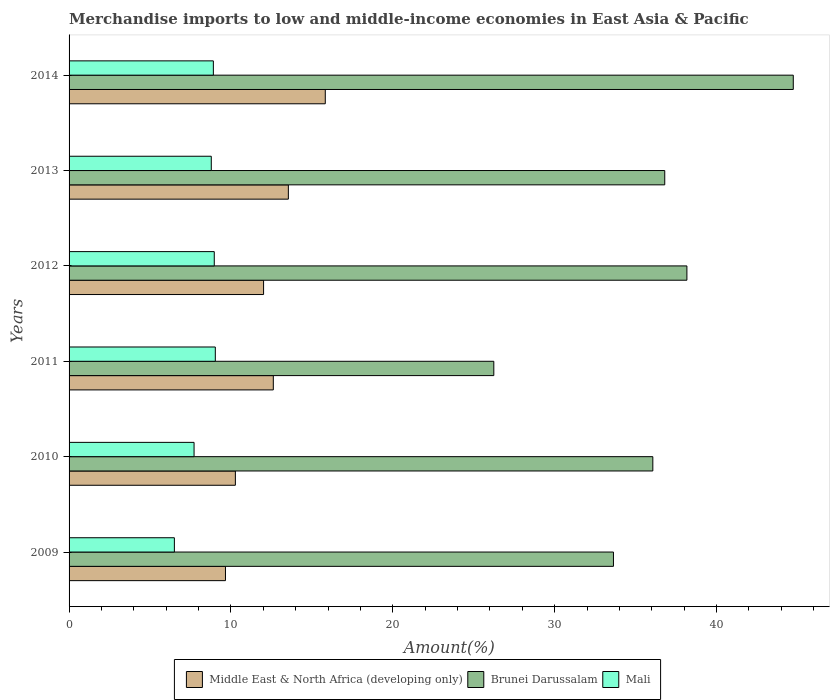How many different coloured bars are there?
Your answer should be very brief. 3. Are the number of bars per tick equal to the number of legend labels?
Your answer should be very brief. Yes. How many bars are there on the 6th tick from the top?
Ensure brevity in your answer.  3. How many bars are there on the 6th tick from the bottom?
Offer a terse response. 3. What is the percentage of amount earned from merchandise imports in Brunei Darussalam in 2011?
Give a very brief answer. 26.24. Across all years, what is the maximum percentage of amount earned from merchandise imports in Mali?
Ensure brevity in your answer.  9.04. Across all years, what is the minimum percentage of amount earned from merchandise imports in Brunei Darussalam?
Offer a terse response. 26.24. What is the total percentage of amount earned from merchandise imports in Middle East & North Africa (developing only) in the graph?
Offer a very short reply. 73.95. What is the difference between the percentage of amount earned from merchandise imports in Middle East & North Africa (developing only) in 2009 and that in 2012?
Ensure brevity in your answer.  -2.35. What is the difference between the percentage of amount earned from merchandise imports in Middle East & North Africa (developing only) in 2010 and the percentage of amount earned from merchandise imports in Mali in 2014?
Your answer should be compact. 1.36. What is the average percentage of amount earned from merchandise imports in Mali per year?
Provide a short and direct response. 8.32. In the year 2012, what is the difference between the percentage of amount earned from merchandise imports in Middle East & North Africa (developing only) and percentage of amount earned from merchandise imports in Mali?
Provide a succinct answer. 3.05. What is the ratio of the percentage of amount earned from merchandise imports in Middle East & North Africa (developing only) in 2011 to that in 2014?
Make the answer very short. 0.8. Is the percentage of amount earned from merchandise imports in Mali in 2009 less than that in 2010?
Make the answer very short. Yes. Is the difference between the percentage of amount earned from merchandise imports in Middle East & North Africa (developing only) in 2010 and 2012 greater than the difference between the percentage of amount earned from merchandise imports in Mali in 2010 and 2012?
Keep it short and to the point. No. What is the difference between the highest and the second highest percentage of amount earned from merchandise imports in Mali?
Provide a succinct answer. 0.06. What is the difference between the highest and the lowest percentage of amount earned from merchandise imports in Middle East & North Africa (developing only)?
Keep it short and to the point. 6.17. Is the sum of the percentage of amount earned from merchandise imports in Mali in 2012 and 2013 greater than the maximum percentage of amount earned from merchandise imports in Brunei Darussalam across all years?
Your response must be concise. No. What does the 2nd bar from the top in 2013 represents?
Offer a terse response. Brunei Darussalam. What does the 1st bar from the bottom in 2014 represents?
Offer a very short reply. Middle East & North Africa (developing only). How many bars are there?
Offer a very short reply. 18. Are all the bars in the graph horizontal?
Provide a succinct answer. Yes. How many years are there in the graph?
Make the answer very short. 6. What is the difference between two consecutive major ticks on the X-axis?
Keep it short and to the point. 10. Does the graph contain grids?
Ensure brevity in your answer.  No. How many legend labels are there?
Offer a very short reply. 3. How are the legend labels stacked?
Make the answer very short. Horizontal. What is the title of the graph?
Offer a very short reply. Merchandise imports to low and middle-income economies in East Asia & Pacific. What is the label or title of the X-axis?
Ensure brevity in your answer.  Amount(%). What is the label or title of the Y-axis?
Give a very brief answer. Years. What is the Amount(%) of Middle East & North Africa (developing only) in 2009?
Your answer should be very brief. 9.66. What is the Amount(%) in Brunei Darussalam in 2009?
Your answer should be very brief. 33.63. What is the Amount(%) of Mali in 2009?
Your answer should be compact. 6.51. What is the Amount(%) in Middle East & North Africa (developing only) in 2010?
Give a very brief answer. 10.28. What is the Amount(%) in Brunei Darussalam in 2010?
Provide a short and direct response. 36.07. What is the Amount(%) in Mali in 2010?
Your answer should be very brief. 7.72. What is the Amount(%) in Middle East & North Africa (developing only) in 2011?
Keep it short and to the point. 12.62. What is the Amount(%) in Brunei Darussalam in 2011?
Keep it short and to the point. 26.24. What is the Amount(%) of Mali in 2011?
Keep it short and to the point. 9.04. What is the Amount(%) in Middle East & North Africa (developing only) in 2012?
Keep it short and to the point. 12.02. What is the Amount(%) in Brunei Darussalam in 2012?
Give a very brief answer. 38.17. What is the Amount(%) of Mali in 2012?
Your answer should be compact. 8.97. What is the Amount(%) of Middle East & North Africa (developing only) in 2013?
Ensure brevity in your answer.  13.55. What is the Amount(%) of Brunei Darussalam in 2013?
Provide a short and direct response. 36.8. What is the Amount(%) in Mali in 2013?
Keep it short and to the point. 8.79. What is the Amount(%) in Middle East & North Africa (developing only) in 2014?
Your response must be concise. 15.83. What is the Amount(%) in Brunei Darussalam in 2014?
Provide a short and direct response. 44.74. What is the Amount(%) of Mali in 2014?
Provide a succinct answer. 8.91. Across all years, what is the maximum Amount(%) of Middle East & North Africa (developing only)?
Your answer should be compact. 15.83. Across all years, what is the maximum Amount(%) in Brunei Darussalam?
Make the answer very short. 44.74. Across all years, what is the maximum Amount(%) of Mali?
Provide a short and direct response. 9.04. Across all years, what is the minimum Amount(%) in Middle East & North Africa (developing only)?
Offer a very short reply. 9.66. Across all years, what is the minimum Amount(%) in Brunei Darussalam?
Offer a terse response. 26.24. Across all years, what is the minimum Amount(%) in Mali?
Provide a succinct answer. 6.51. What is the total Amount(%) in Middle East & North Africa (developing only) in the graph?
Make the answer very short. 73.95. What is the total Amount(%) of Brunei Darussalam in the graph?
Provide a succinct answer. 215.67. What is the total Amount(%) in Mali in the graph?
Your response must be concise. 49.94. What is the difference between the Amount(%) of Middle East & North Africa (developing only) in 2009 and that in 2010?
Offer a terse response. -0.61. What is the difference between the Amount(%) of Brunei Darussalam in 2009 and that in 2010?
Offer a very short reply. -2.43. What is the difference between the Amount(%) of Mali in 2009 and that in 2010?
Ensure brevity in your answer.  -1.22. What is the difference between the Amount(%) of Middle East & North Africa (developing only) in 2009 and that in 2011?
Ensure brevity in your answer.  -2.96. What is the difference between the Amount(%) in Brunei Darussalam in 2009 and that in 2011?
Provide a short and direct response. 7.39. What is the difference between the Amount(%) of Mali in 2009 and that in 2011?
Offer a very short reply. -2.53. What is the difference between the Amount(%) of Middle East & North Africa (developing only) in 2009 and that in 2012?
Your response must be concise. -2.35. What is the difference between the Amount(%) in Brunei Darussalam in 2009 and that in 2012?
Offer a terse response. -4.54. What is the difference between the Amount(%) in Mali in 2009 and that in 2012?
Your response must be concise. -2.46. What is the difference between the Amount(%) of Middle East & North Africa (developing only) in 2009 and that in 2013?
Provide a succinct answer. -3.89. What is the difference between the Amount(%) in Brunei Darussalam in 2009 and that in 2013?
Keep it short and to the point. -3.17. What is the difference between the Amount(%) in Mali in 2009 and that in 2013?
Ensure brevity in your answer.  -2.28. What is the difference between the Amount(%) in Middle East & North Africa (developing only) in 2009 and that in 2014?
Give a very brief answer. -6.17. What is the difference between the Amount(%) of Brunei Darussalam in 2009 and that in 2014?
Make the answer very short. -11.11. What is the difference between the Amount(%) of Mali in 2009 and that in 2014?
Keep it short and to the point. -2.41. What is the difference between the Amount(%) of Middle East & North Africa (developing only) in 2010 and that in 2011?
Keep it short and to the point. -2.34. What is the difference between the Amount(%) of Brunei Darussalam in 2010 and that in 2011?
Offer a very short reply. 9.82. What is the difference between the Amount(%) of Mali in 2010 and that in 2011?
Your answer should be very brief. -1.31. What is the difference between the Amount(%) of Middle East & North Africa (developing only) in 2010 and that in 2012?
Give a very brief answer. -1.74. What is the difference between the Amount(%) in Brunei Darussalam in 2010 and that in 2012?
Provide a succinct answer. -2.11. What is the difference between the Amount(%) of Mali in 2010 and that in 2012?
Your answer should be compact. -1.25. What is the difference between the Amount(%) of Middle East & North Africa (developing only) in 2010 and that in 2013?
Give a very brief answer. -3.27. What is the difference between the Amount(%) in Brunei Darussalam in 2010 and that in 2013?
Make the answer very short. -0.74. What is the difference between the Amount(%) of Mali in 2010 and that in 2013?
Provide a short and direct response. -1.06. What is the difference between the Amount(%) of Middle East & North Africa (developing only) in 2010 and that in 2014?
Keep it short and to the point. -5.55. What is the difference between the Amount(%) in Brunei Darussalam in 2010 and that in 2014?
Your response must be concise. -8.68. What is the difference between the Amount(%) of Mali in 2010 and that in 2014?
Your response must be concise. -1.19. What is the difference between the Amount(%) of Middle East & North Africa (developing only) in 2011 and that in 2012?
Offer a very short reply. 0.6. What is the difference between the Amount(%) of Brunei Darussalam in 2011 and that in 2012?
Make the answer very short. -11.93. What is the difference between the Amount(%) of Mali in 2011 and that in 2012?
Your response must be concise. 0.06. What is the difference between the Amount(%) of Middle East & North Africa (developing only) in 2011 and that in 2013?
Your answer should be very brief. -0.93. What is the difference between the Amount(%) of Brunei Darussalam in 2011 and that in 2013?
Your answer should be compact. -10.56. What is the difference between the Amount(%) of Mali in 2011 and that in 2013?
Your answer should be compact. 0.25. What is the difference between the Amount(%) in Middle East & North Africa (developing only) in 2011 and that in 2014?
Offer a terse response. -3.21. What is the difference between the Amount(%) of Brunei Darussalam in 2011 and that in 2014?
Provide a succinct answer. -18.5. What is the difference between the Amount(%) in Mali in 2011 and that in 2014?
Keep it short and to the point. 0.12. What is the difference between the Amount(%) of Middle East & North Africa (developing only) in 2012 and that in 2013?
Ensure brevity in your answer.  -1.53. What is the difference between the Amount(%) of Brunei Darussalam in 2012 and that in 2013?
Keep it short and to the point. 1.37. What is the difference between the Amount(%) of Mali in 2012 and that in 2013?
Give a very brief answer. 0.18. What is the difference between the Amount(%) in Middle East & North Africa (developing only) in 2012 and that in 2014?
Offer a very short reply. -3.81. What is the difference between the Amount(%) in Brunei Darussalam in 2012 and that in 2014?
Your response must be concise. -6.57. What is the difference between the Amount(%) in Mali in 2012 and that in 2014?
Provide a short and direct response. 0.06. What is the difference between the Amount(%) of Middle East & North Africa (developing only) in 2013 and that in 2014?
Provide a succinct answer. -2.28. What is the difference between the Amount(%) in Brunei Darussalam in 2013 and that in 2014?
Provide a succinct answer. -7.94. What is the difference between the Amount(%) in Mali in 2013 and that in 2014?
Keep it short and to the point. -0.13. What is the difference between the Amount(%) of Middle East & North Africa (developing only) in 2009 and the Amount(%) of Brunei Darussalam in 2010?
Offer a terse response. -26.4. What is the difference between the Amount(%) in Middle East & North Africa (developing only) in 2009 and the Amount(%) in Mali in 2010?
Provide a succinct answer. 1.94. What is the difference between the Amount(%) of Brunei Darussalam in 2009 and the Amount(%) of Mali in 2010?
Ensure brevity in your answer.  25.91. What is the difference between the Amount(%) of Middle East & North Africa (developing only) in 2009 and the Amount(%) of Brunei Darussalam in 2011?
Make the answer very short. -16.58. What is the difference between the Amount(%) in Middle East & North Africa (developing only) in 2009 and the Amount(%) in Mali in 2011?
Your answer should be compact. 0.63. What is the difference between the Amount(%) in Brunei Darussalam in 2009 and the Amount(%) in Mali in 2011?
Offer a very short reply. 24.6. What is the difference between the Amount(%) in Middle East & North Africa (developing only) in 2009 and the Amount(%) in Brunei Darussalam in 2012?
Give a very brief answer. -28.51. What is the difference between the Amount(%) in Middle East & North Africa (developing only) in 2009 and the Amount(%) in Mali in 2012?
Your response must be concise. 0.69. What is the difference between the Amount(%) of Brunei Darussalam in 2009 and the Amount(%) of Mali in 2012?
Provide a succinct answer. 24.66. What is the difference between the Amount(%) in Middle East & North Africa (developing only) in 2009 and the Amount(%) in Brunei Darussalam in 2013?
Keep it short and to the point. -27.14. What is the difference between the Amount(%) in Middle East & North Africa (developing only) in 2009 and the Amount(%) in Mali in 2013?
Your answer should be compact. 0.88. What is the difference between the Amount(%) in Brunei Darussalam in 2009 and the Amount(%) in Mali in 2013?
Your answer should be compact. 24.85. What is the difference between the Amount(%) of Middle East & North Africa (developing only) in 2009 and the Amount(%) of Brunei Darussalam in 2014?
Offer a very short reply. -35.08. What is the difference between the Amount(%) in Middle East & North Africa (developing only) in 2009 and the Amount(%) in Mali in 2014?
Your response must be concise. 0.75. What is the difference between the Amount(%) of Brunei Darussalam in 2009 and the Amount(%) of Mali in 2014?
Provide a succinct answer. 24.72. What is the difference between the Amount(%) in Middle East & North Africa (developing only) in 2010 and the Amount(%) in Brunei Darussalam in 2011?
Your response must be concise. -15.97. What is the difference between the Amount(%) in Middle East & North Africa (developing only) in 2010 and the Amount(%) in Mali in 2011?
Your answer should be very brief. 1.24. What is the difference between the Amount(%) of Brunei Darussalam in 2010 and the Amount(%) of Mali in 2011?
Keep it short and to the point. 27.03. What is the difference between the Amount(%) of Middle East & North Africa (developing only) in 2010 and the Amount(%) of Brunei Darussalam in 2012?
Offer a terse response. -27.9. What is the difference between the Amount(%) in Middle East & North Africa (developing only) in 2010 and the Amount(%) in Mali in 2012?
Provide a succinct answer. 1.3. What is the difference between the Amount(%) in Brunei Darussalam in 2010 and the Amount(%) in Mali in 2012?
Provide a succinct answer. 27.1. What is the difference between the Amount(%) of Middle East & North Africa (developing only) in 2010 and the Amount(%) of Brunei Darussalam in 2013?
Offer a very short reply. -26.53. What is the difference between the Amount(%) of Middle East & North Africa (developing only) in 2010 and the Amount(%) of Mali in 2013?
Provide a short and direct response. 1.49. What is the difference between the Amount(%) of Brunei Darussalam in 2010 and the Amount(%) of Mali in 2013?
Your answer should be very brief. 27.28. What is the difference between the Amount(%) of Middle East & North Africa (developing only) in 2010 and the Amount(%) of Brunei Darussalam in 2014?
Give a very brief answer. -34.47. What is the difference between the Amount(%) of Middle East & North Africa (developing only) in 2010 and the Amount(%) of Mali in 2014?
Provide a short and direct response. 1.36. What is the difference between the Amount(%) of Brunei Darussalam in 2010 and the Amount(%) of Mali in 2014?
Your answer should be compact. 27.15. What is the difference between the Amount(%) of Middle East & North Africa (developing only) in 2011 and the Amount(%) of Brunei Darussalam in 2012?
Your answer should be very brief. -25.55. What is the difference between the Amount(%) in Middle East & North Africa (developing only) in 2011 and the Amount(%) in Mali in 2012?
Make the answer very short. 3.65. What is the difference between the Amount(%) of Brunei Darussalam in 2011 and the Amount(%) of Mali in 2012?
Offer a terse response. 17.27. What is the difference between the Amount(%) in Middle East & North Africa (developing only) in 2011 and the Amount(%) in Brunei Darussalam in 2013?
Offer a terse response. -24.18. What is the difference between the Amount(%) in Middle East & North Africa (developing only) in 2011 and the Amount(%) in Mali in 2013?
Make the answer very short. 3.83. What is the difference between the Amount(%) of Brunei Darussalam in 2011 and the Amount(%) of Mali in 2013?
Offer a very short reply. 17.46. What is the difference between the Amount(%) of Middle East & North Africa (developing only) in 2011 and the Amount(%) of Brunei Darussalam in 2014?
Provide a short and direct response. -32.13. What is the difference between the Amount(%) in Middle East & North Africa (developing only) in 2011 and the Amount(%) in Mali in 2014?
Ensure brevity in your answer.  3.7. What is the difference between the Amount(%) in Brunei Darussalam in 2011 and the Amount(%) in Mali in 2014?
Your answer should be compact. 17.33. What is the difference between the Amount(%) of Middle East & North Africa (developing only) in 2012 and the Amount(%) of Brunei Darussalam in 2013?
Provide a succinct answer. -24.79. What is the difference between the Amount(%) in Middle East & North Africa (developing only) in 2012 and the Amount(%) in Mali in 2013?
Offer a terse response. 3.23. What is the difference between the Amount(%) in Brunei Darussalam in 2012 and the Amount(%) in Mali in 2013?
Make the answer very short. 29.39. What is the difference between the Amount(%) in Middle East & North Africa (developing only) in 2012 and the Amount(%) in Brunei Darussalam in 2014?
Your response must be concise. -32.73. What is the difference between the Amount(%) in Middle East & North Africa (developing only) in 2012 and the Amount(%) in Mali in 2014?
Provide a short and direct response. 3.1. What is the difference between the Amount(%) of Brunei Darussalam in 2012 and the Amount(%) of Mali in 2014?
Ensure brevity in your answer.  29.26. What is the difference between the Amount(%) in Middle East & North Africa (developing only) in 2013 and the Amount(%) in Brunei Darussalam in 2014?
Offer a very short reply. -31.2. What is the difference between the Amount(%) of Middle East & North Africa (developing only) in 2013 and the Amount(%) of Mali in 2014?
Provide a short and direct response. 4.63. What is the difference between the Amount(%) in Brunei Darussalam in 2013 and the Amount(%) in Mali in 2014?
Give a very brief answer. 27.89. What is the average Amount(%) in Middle East & North Africa (developing only) per year?
Make the answer very short. 12.33. What is the average Amount(%) in Brunei Darussalam per year?
Offer a very short reply. 35.94. What is the average Amount(%) of Mali per year?
Make the answer very short. 8.32. In the year 2009, what is the difference between the Amount(%) in Middle East & North Africa (developing only) and Amount(%) in Brunei Darussalam?
Provide a succinct answer. -23.97. In the year 2009, what is the difference between the Amount(%) in Middle East & North Africa (developing only) and Amount(%) in Mali?
Your answer should be compact. 3.16. In the year 2009, what is the difference between the Amount(%) in Brunei Darussalam and Amount(%) in Mali?
Provide a short and direct response. 27.13. In the year 2010, what is the difference between the Amount(%) in Middle East & North Africa (developing only) and Amount(%) in Brunei Darussalam?
Make the answer very short. -25.79. In the year 2010, what is the difference between the Amount(%) of Middle East & North Africa (developing only) and Amount(%) of Mali?
Provide a short and direct response. 2.55. In the year 2010, what is the difference between the Amount(%) of Brunei Darussalam and Amount(%) of Mali?
Your response must be concise. 28.34. In the year 2011, what is the difference between the Amount(%) of Middle East & North Africa (developing only) and Amount(%) of Brunei Darussalam?
Keep it short and to the point. -13.62. In the year 2011, what is the difference between the Amount(%) in Middle East & North Africa (developing only) and Amount(%) in Mali?
Offer a terse response. 3.58. In the year 2011, what is the difference between the Amount(%) in Brunei Darussalam and Amount(%) in Mali?
Ensure brevity in your answer.  17.21. In the year 2012, what is the difference between the Amount(%) in Middle East & North Africa (developing only) and Amount(%) in Brunei Darussalam?
Keep it short and to the point. -26.15. In the year 2012, what is the difference between the Amount(%) of Middle East & North Africa (developing only) and Amount(%) of Mali?
Provide a short and direct response. 3.05. In the year 2012, what is the difference between the Amount(%) in Brunei Darussalam and Amount(%) in Mali?
Give a very brief answer. 29.2. In the year 2013, what is the difference between the Amount(%) in Middle East & North Africa (developing only) and Amount(%) in Brunei Darussalam?
Give a very brief answer. -23.26. In the year 2013, what is the difference between the Amount(%) in Middle East & North Africa (developing only) and Amount(%) in Mali?
Ensure brevity in your answer.  4.76. In the year 2013, what is the difference between the Amount(%) in Brunei Darussalam and Amount(%) in Mali?
Make the answer very short. 28.02. In the year 2014, what is the difference between the Amount(%) of Middle East & North Africa (developing only) and Amount(%) of Brunei Darussalam?
Offer a terse response. -28.91. In the year 2014, what is the difference between the Amount(%) in Middle East & North Africa (developing only) and Amount(%) in Mali?
Ensure brevity in your answer.  6.92. In the year 2014, what is the difference between the Amount(%) of Brunei Darussalam and Amount(%) of Mali?
Provide a short and direct response. 35.83. What is the ratio of the Amount(%) of Middle East & North Africa (developing only) in 2009 to that in 2010?
Give a very brief answer. 0.94. What is the ratio of the Amount(%) in Brunei Darussalam in 2009 to that in 2010?
Provide a short and direct response. 0.93. What is the ratio of the Amount(%) in Mali in 2009 to that in 2010?
Your answer should be compact. 0.84. What is the ratio of the Amount(%) in Middle East & North Africa (developing only) in 2009 to that in 2011?
Offer a very short reply. 0.77. What is the ratio of the Amount(%) of Brunei Darussalam in 2009 to that in 2011?
Your answer should be compact. 1.28. What is the ratio of the Amount(%) of Mali in 2009 to that in 2011?
Make the answer very short. 0.72. What is the ratio of the Amount(%) in Middle East & North Africa (developing only) in 2009 to that in 2012?
Provide a short and direct response. 0.8. What is the ratio of the Amount(%) of Brunei Darussalam in 2009 to that in 2012?
Provide a succinct answer. 0.88. What is the ratio of the Amount(%) in Mali in 2009 to that in 2012?
Ensure brevity in your answer.  0.73. What is the ratio of the Amount(%) in Middle East & North Africa (developing only) in 2009 to that in 2013?
Ensure brevity in your answer.  0.71. What is the ratio of the Amount(%) in Brunei Darussalam in 2009 to that in 2013?
Your response must be concise. 0.91. What is the ratio of the Amount(%) in Mali in 2009 to that in 2013?
Your answer should be very brief. 0.74. What is the ratio of the Amount(%) of Middle East & North Africa (developing only) in 2009 to that in 2014?
Give a very brief answer. 0.61. What is the ratio of the Amount(%) in Brunei Darussalam in 2009 to that in 2014?
Give a very brief answer. 0.75. What is the ratio of the Amount(%) of Mali in 2009 to that in 2014?
Your response must be concise. 0.73. What is the ratio of the Amount(%) of Middle East & North Africa (developing only) in 2010 to that in 2011?
Ensure brevity in your answer.  0.81. What is the ratio of the Amount(%) in Brunei Darussalam in 2010 to that in 2011?
Provide a succinct answer. 1.37. What is the ratio of the Amount(%) of Mali in 2010 to that in 2011?
Provide a short and direct response. 0.85. What is the ratio of the Amount(%) of Middle East & North Africa (developing only) in 2010 to that in 2012?
Offer a terse response. 0.85. What is the ratio of the Amount(%) in Brunei Darussalam in 2010 to that in 2012?
Provide a short and direct response. 0.94. What is the ratio of the Amount(%) of Mali in 2010 to that in 2012?
Offer a very short reply. 0.86. What is the ratio of the Amount(%) of Middle East & North Africa (developing only) in 2010 to that in 2013?
Your answer should be very brief. 0.76. What is the ratio of the Amount(%) of Brunei Darussalam in 2010 to that in 2013?
Ensure brevity in your answer.  0.98. What is the ratio of the Amount(%) in Mali in 2010 to that in 2013?
Offer a very short reply. 0.88. What is the ratio of the Amount(%) of Middle East & North Africa (developing only) in 2010 to that in 2014?
Provide a short and direct response. 0.65. What is the ratio of the Amount(%) of Brunei Darussalam in 2010 to that in 2014?
Offer a terse response. 0.81. What is the ratio of the Amount(%) of Mali in 2010 to that in 2014?
Ensure brevity in your answer.  0.87. What is the ratio of the Amount(%) in Middle East & North Africa (developing only) in 2011 to that in 2012?
Ensure brevity in your answer.  1.05. What is the ratio of the Amount(%) in Brunei Darussalam in 2011 to that in 2012?
Your response must be concise. 0.69. What is the ratio of the Amount(%) of Middle East & North Africa (developing only) in 2011 to that in 2013?
Make the answer very short. 0.93. What is the ratio of the Amount(%) of Brunei Darussalam in 2011 to that in 2013?
Keep it short and to the point. 0.71. What is the ratio of the Amount(%) in Mali in 2011 to that in 2013?
Your answer should be very brief. 1.03. What is the ratio of the Amount(%) of Middle East & North Africa (developing only) in 2011 to that in 2014?
Ensure brevity in your answer.  0.8. What is the ratio of the Amount(%) in Brunei Darussalam in 2011 to that in 2014?
Provide a succinct answer. 0.59. What is the ratio of the Amount(%) of Mali in 2011 to that in 2014?
Offer a terse response. 1.01. What is the ratio of the Amount(%) in Middle East & North Africa (developing only) in 2012 to that in 2013?
Provide a succinct answer. 0.89. What is the ratio of the Amount(%) in Brunei Darussalam in 2012 to that in 2013?
Offer a very short reply. 1.04. What is the ratio of the Amount(%) of Mali in 2012 to that in 2013?
Provide a succinct answer. 1.02. What is the ratio of the Amount(%) of Middle East & North Africa (developing only) in 2012 to that in 2014?
Your answer should be compact. 0.76. What is the ratio of the Amount(%) in Brunei Darussalam in 2012 to that in 2014?
Provide a succinct answer. 0.85. What is the ratio of the Amount(%) of Middle East & North Africa (developing only) in 2013 to that in 2014?
Your answer should be compact. 0.86. What is the ratio of the Amount(%) in Brunei Darussalam in 2013 to that in 2014?
Give a very brief answer. 0.82. What is the ratio of the Amount(%) in Mali in 2013 to that in 2014?
Your response must be concise. 0.99. What is the difference between the highest and the second highest Amount(%) in Middle East & North Africa (developing only)?
Give a very brief answer. 2.28. What is the difference between the highest and the second highest Amount(%) of Brunei Darussalam?
Give a very brief answer. 6.57. What is the difference between the highest and the second highest Amount(%) of Mali?
Provide a succinct answer. 0.06. What is the difference between the highest and the lowest Amount(%) of Middle East & North Africa (developing only)?
Make the answer very short. 6.17. What is the difference between the highest and the lowest Amount(%) in Brunei Darussalam?
Your answer should be compact. 18.5. What is the difference between the highest and the lowest Amount(%) of Mali?
Keep it short and to the point. 2.53. 